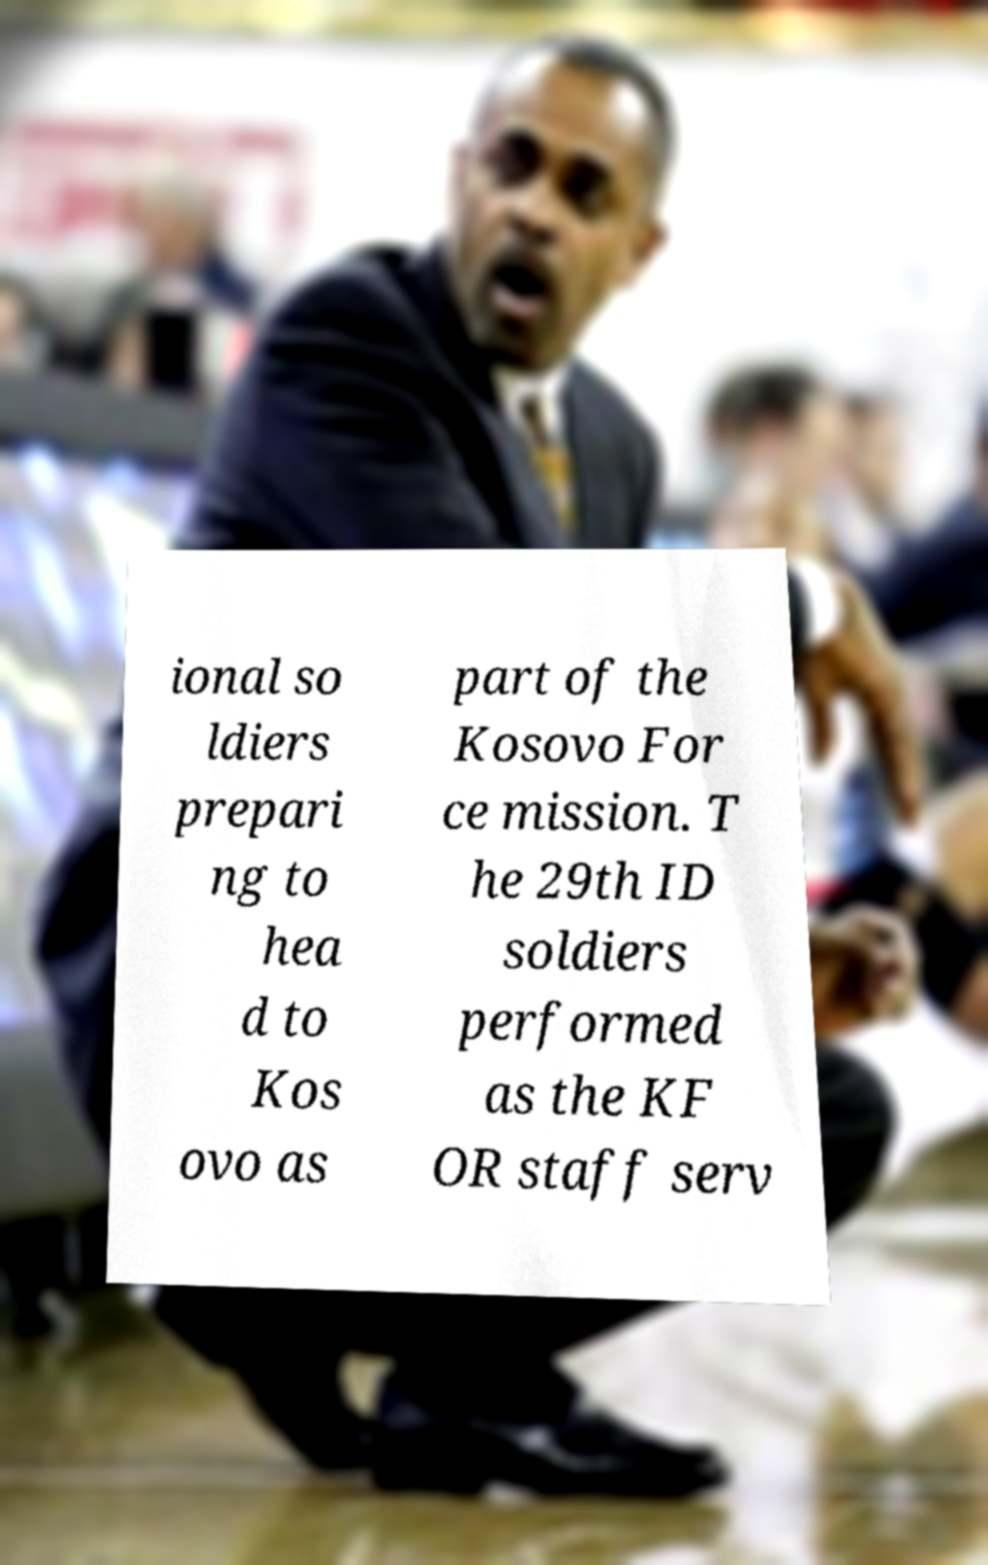Can you read and provide the text displayed in the image?This photo seems to have some interesting text. Can you extract and type it out for me? ional so ldiers prepari ng to hea d to Kos ovo as part of the Kosovo For ce mission. T he 29th ID soldiers performed as the KF OR staff serv 